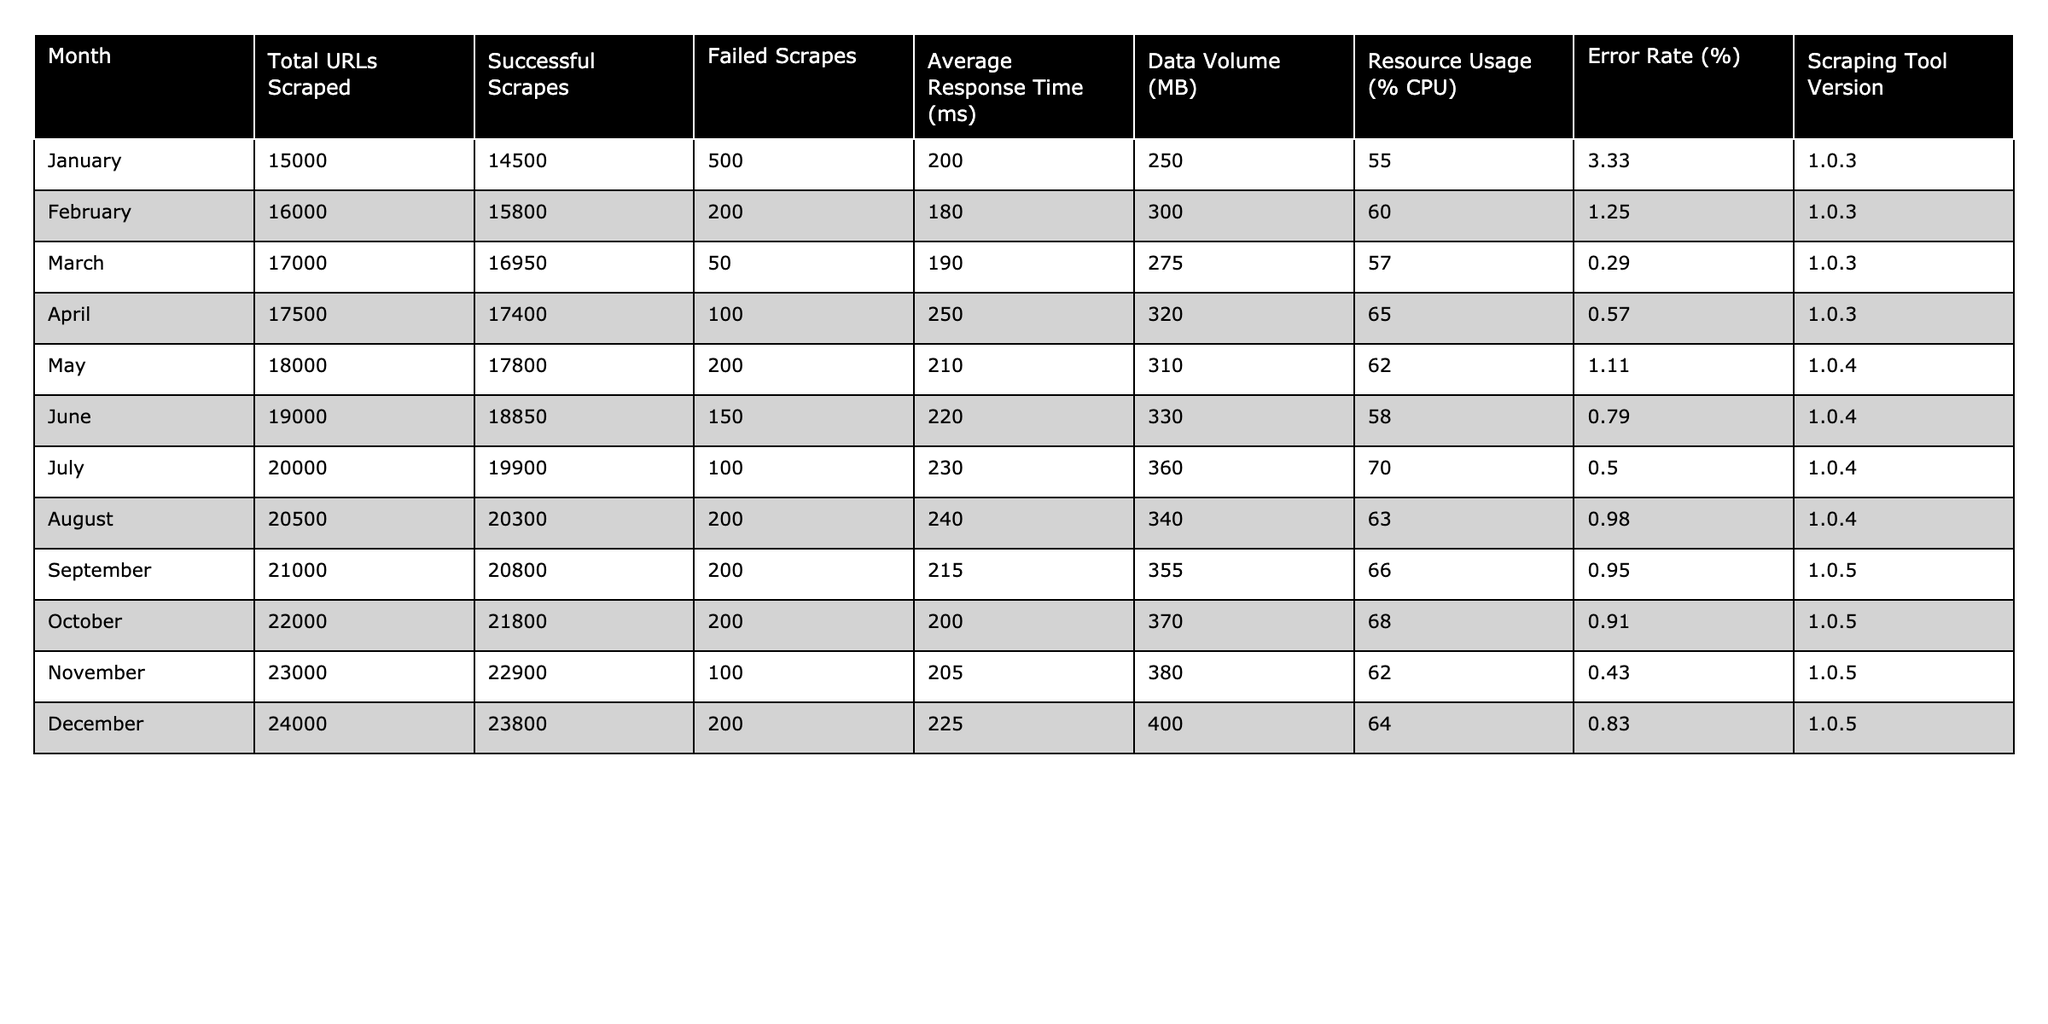What was the highest number of successful scrapes in one month? Looking at the "Successful Scrapes" column, the highest value is 23800 in December.
Answer: 23800 What was the average response time in March? The "Average Response Time (ms)" for March is listed as 190.
Answer: 190 In which month did resource usage exceed 65%? Reviewing the "Resource Usage (% CPU)" column, it is noted that only April (65%) and July (70%) exceed or meet this threshold.
Answer: April and July What was the total number of failed scrapes across all months? Adding the values in the "Failed Scrapes" column gives a total of (500 + 200 + 50 + 100 + 200 + 150 + 100 + 200 + 200 + 200 + 100 + 200) = 22,100.
Answer: 22100 Was the error rate lower in February than in March? The "Error Rate (%)" for February is 1.25%, while for March it is 0.29%. Since 0.29% is lower than 1.25%, the statement is true.
Answer: Yes How much did the total URLs scraped increase from January to December? The increase can be calculated by subtracting the January total (15000) from the December total (24000), resulting in 24000 - 15000 = 9000.
Answer: 9000 What was the average data volume in the second quarter (April to June)? Summing the data volumes for April (320 MB), May (310 MB), and June (330 MB) gives 320 + 310 + 330 = 960 MB. Dividing by the number of months (3), the average is 960 / 3 = 320.
Answer: 320 In which month did the scraping tool version change to 1.0.4? The version changes to 1.0.4 in May, according to the "Scraping Tool Version" column.
Answer: May What was the maximum error rate observed, and in which month did it occur? The maximum error rate is 3.33% in January, as seen in the "Error Rate (%)" column.
Answer: 3.33% in January Was the total number of URLs scraped higher in December than in September? December had 24000 URLs scraped compared to September's 21000, indicating that December's total was higher.
Answer: Yes 